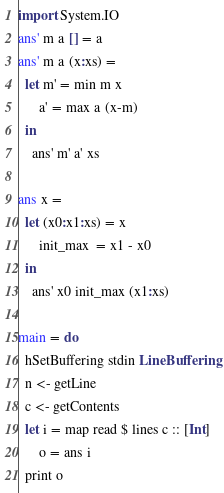<code> <loc_0><loc_0><loc_500><loc_500><_Haskell_>import System.IO
ans' m a [] = a
ans' m a (x:xs) = 
  let m' = min m x
      a' = max a (x-m)
  in
    ans' m' a' xs

ans x = 
  let (x0:x1:xs) = x
      init_max  = x1 - x0
  in
    ans' x0 init_max (x1:xs)

main = do
  hSetBuffering stdin LineBuffering
  n <- getLine
  c <- getContents
  let i = map read $ lines c :: [Int]
      o = ans i
  print o</code> 